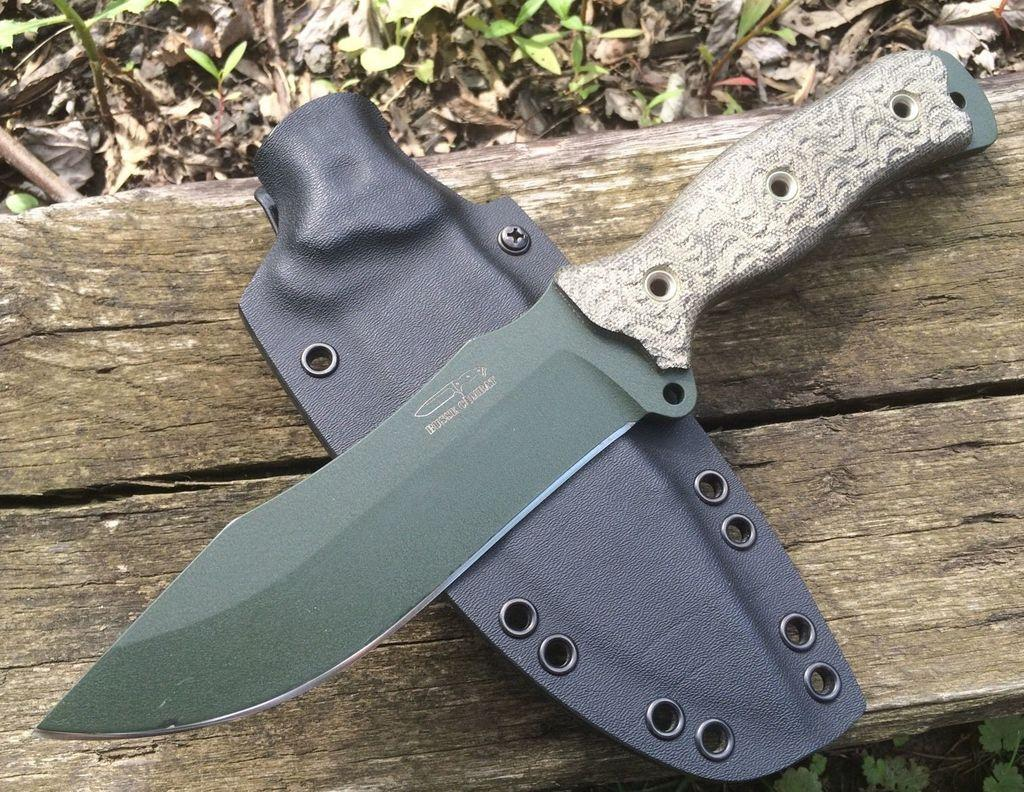What object is placed on the bench in the image? There is a knife on the bench. What other item can be seen on the bench? There is a pouch on the bench. What type of natural elements are visible in the image? There are leaves visible in the image. What shape is the sky in the image? The sky does not have a shape in the image, as the sky is not an object with a defined shape. 